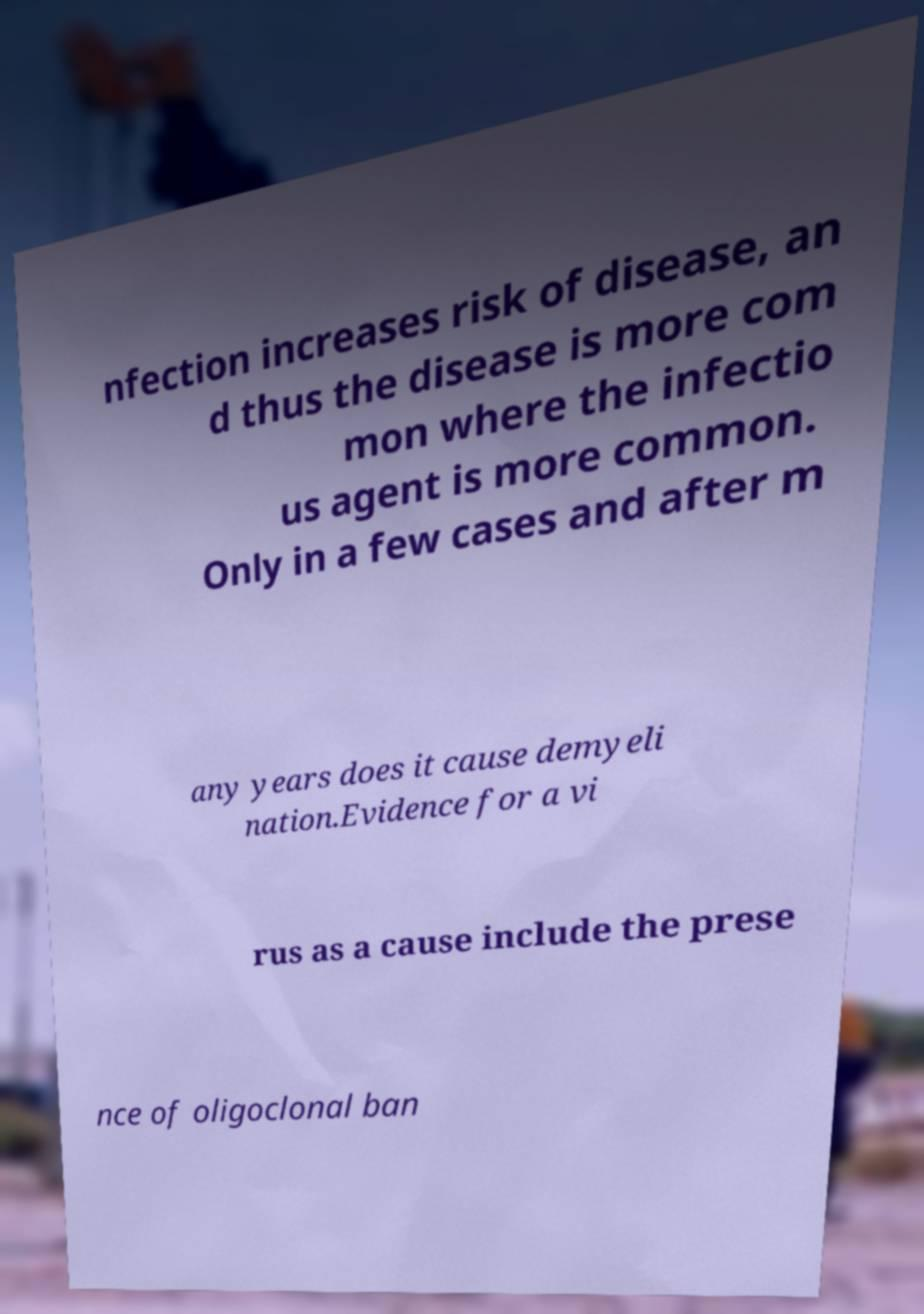Please identify and transcribe the text found in this image. nfection increases risk of disease, an d thus the disease is more com mon where the infectio us agent is more common. Only in a few cases and after m any years does it cause demyeli nation.Evidence for a vi rus as a cause include the prese nce of oligoclonal ban 